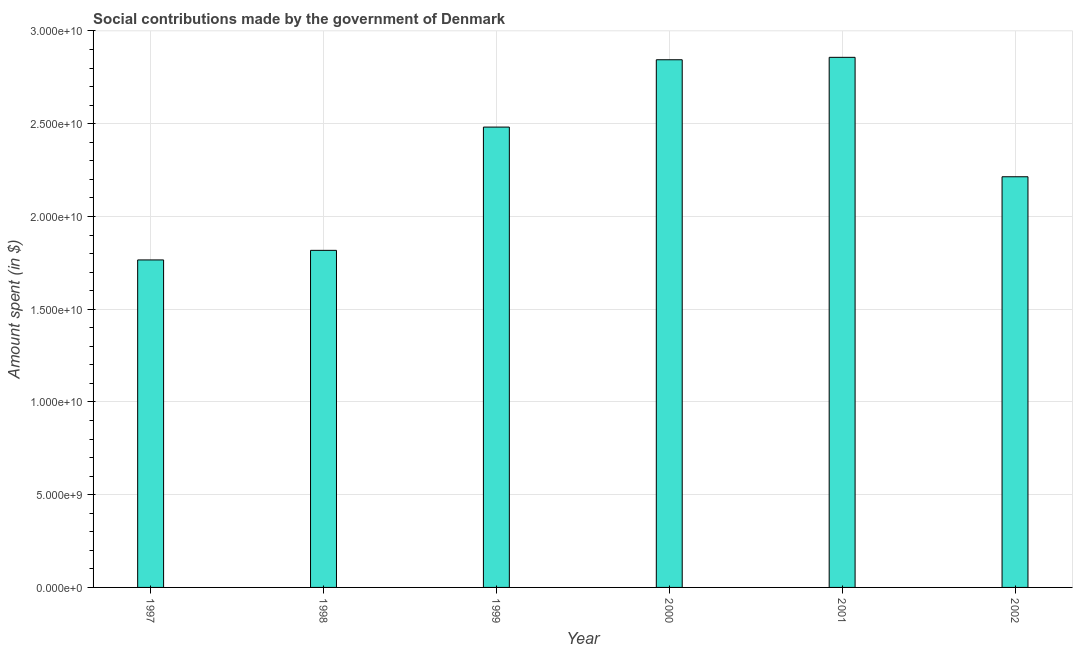Does the graph contain grids?
Keep it short and to the point. Yes. What is the title of the graph?
Provide a succinct answer. Social contributions made by the government of Denmark. What is the label or title of the X-axis?
Make the answer very short. Year. What is the label or title of the Y-axis?
Provide a short and direct response. Amount spent (in $). What is the amount spent in making social contributions in 1997?
Offer a very short reply. 1.77e+1. Across all years, what is the maximum amount spent in making social contributions?
Provide a succinct answer. 2.86e+1. Across all years, what is the minimum amount spent in making social contributions?
Provide a short and direct response. 1.77e+1. In which year was the amount spent in making social contributions maximum?
Offer a very short reply. 2001. What is the sum of the amount spent in making social contributions?
Provide a short and direct response. 1.40e+11. What is the difference between the amount spent in making social contributions in 1998 and 2002?
Ensure brevity in your answer.  -3.97e+09. What is the average amount spent in making social contributions per year?
Provide a short and direct response. 2.33e+1. What is the median amount spent in making social contributions?
Provide a short and direct response. 2.35e+1. What is the ratio of the amount spent in making social contributions in 1997 to that in 2000?
Offer a very short reply. 0.62. Is the amount spent in making social contributions in 1998 less than that in 2001?
Provide a short and direct response. Yes. What is the difference between the highest and the second highest amount spent in making social contributions?
Your answer should be very brief. 1.31e+08. Is the sum of the amount spent in making social contributions in 1997 and 2002 greater than the maximum amount spent in making social contributions across all years?
Offer a terse response. Yes. What is the difference between the highest and the lowest amount spent in making social contributions?
Keep it short and to the point. 1.09e+1. How many years are there in the graph?
Keep it short and to the point. 6. What is the Amount spent (in $) of 1997?
Provide a short and direct response. 1.77e+1. What is the Amount spent (in $) of 1998?
Provide a succinct answer. 1.82e+1. What is the Amount spent (in $) in 1999?
Offer a very short reply. 2.48e+1. What is the Amount spent (in $) in 2000?
Provide a short and direct response. 2.84e+1. What is the Amount spent (in $) in 2001?
Offer a terse response. 2.86e+1. What is the Amount spent (in $) in 2002?
Provide a short and direct response. 2.21e+1. What is the difference between the Amount spent (in $) in 1997 and 1998?
Make the answer very short. -5.17e+08. What is the difference between the Amount spent (in $) in 1997 and 1999?
Provide a succinct answer. -7.16e+09. What is the difference between the Amount spent (in $) in 1997 and 2000?
Give a very brief answer. -1.08e+1. What is the difference between the Amount spent (in $) in 1997 and 2001?
Make the answer very short. -1.09e+1. What is the difference between the Amount spent (in $) in 1997 and 2002?
Ensure brevity in your answer.  -4.48e+09. What is the difference between the Amount spent (in $) in 1998 and 1999?
Provide a short and direct response. -6.64e+09. What is the difference between the Amount spent (in $) in 1998 and 2000?
Your response must be concise. -1.03e+1. What is the difference between the Amount spent (in $) in 1998 and 2001?
Offer a terse response. -1.04e+1. What is the difference between the Amount spent (in $) in 1998 and 2002?
Offer a terse response. -3.97e+09. What is the difference between the Amount spent (in $) in 1999 and 2000?
Provide a succinct answer. -3.63e+09. What is the difference between the Amount spent (in $) in 1999 and 2001?
Ensure brevity in your answer.  -3.76e+09. What is the difference between the Amount spent (in $) in 1999 and 2002?
Your answer should be very brief. 2.68e+09. What is the difference between the Amount spent (in $) in 2000 and 2001?
Your answer should be very brief. -1.31e+08. What is the difference between the Amount spent (in $) in 2000 and 2002?
Your answer should be very brief. 6.31e+09. What is the difference between the Amount spent (in $) in 2001 and 2002?
Your answer should be compact. 6.44e+09. What is the ratio of the Amount spent (in $) in 1997 to that in 1998?
Offer a very short reply. 0.97. What is the ratio of the Amount spent (in $) in 1997 to that in 1999?
Keep it short and to the point. 0.71. What is the ratio of the Amount spent (in $) in 1997 to that in 2000?
Your answer should be very brief. 0.62. What is the ratio of the Amount spent (in $) in 1997 to that in 2001?
Provide a succinct answer. 0.62. What is the ratio of the Amount spent (in $) in 1997 to that in 2002?
Give a very brief answer. 0.8. What is the ratio of the Amount spent (in $) in 1998 to that in 1999?
Offer a terse response. 0.73. What is the ratio of the Amount spent (in $) in 1998 to that in 2000?
Your answer should be very brief. 0.64. What is the ratio of the Amount spent (in $) in 1998 to that in 2001?
Keep it short and to the point. 0.64. What is the ratio of the Amount spent (in $) in 1998 to that in 2002?
Make the answer very short. 0.82. What is the ratio of the Amount spent (in $) in 1999 to that in 2000?
Offer a terse response. 0.87. What is the ratio of the Amount spent (in $) in 1999 to that in 2001?
Your answer should be compact. 0.87. What is the ratio of the Amount spent (in $) in 1999 to that in 2002?
Your answer should be compact. 1.12. What is the ratio of the Amount spent (in $) in 2000 to that in 2001?
Your response must be concise. 0.99. What is the ratio of the Amount spent (in $) in 2000 to that in 2002?
Give a very brief answer. 1.28. What is the ratio of the Amount spent (in $) in 2001 to that in 2002?
Offer a very short reply. 1.29. 